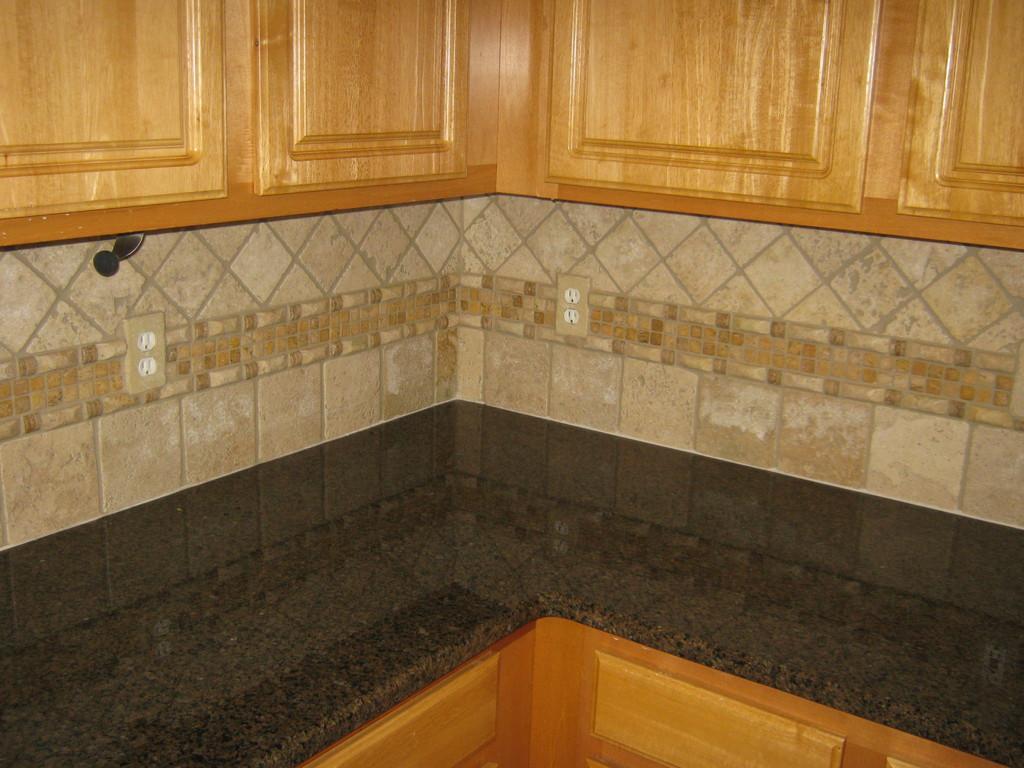How would you summarize this image in a sentence or two? At the bottom of the image we can see a countertop. At the top there are cupboards and we can see a wall. 